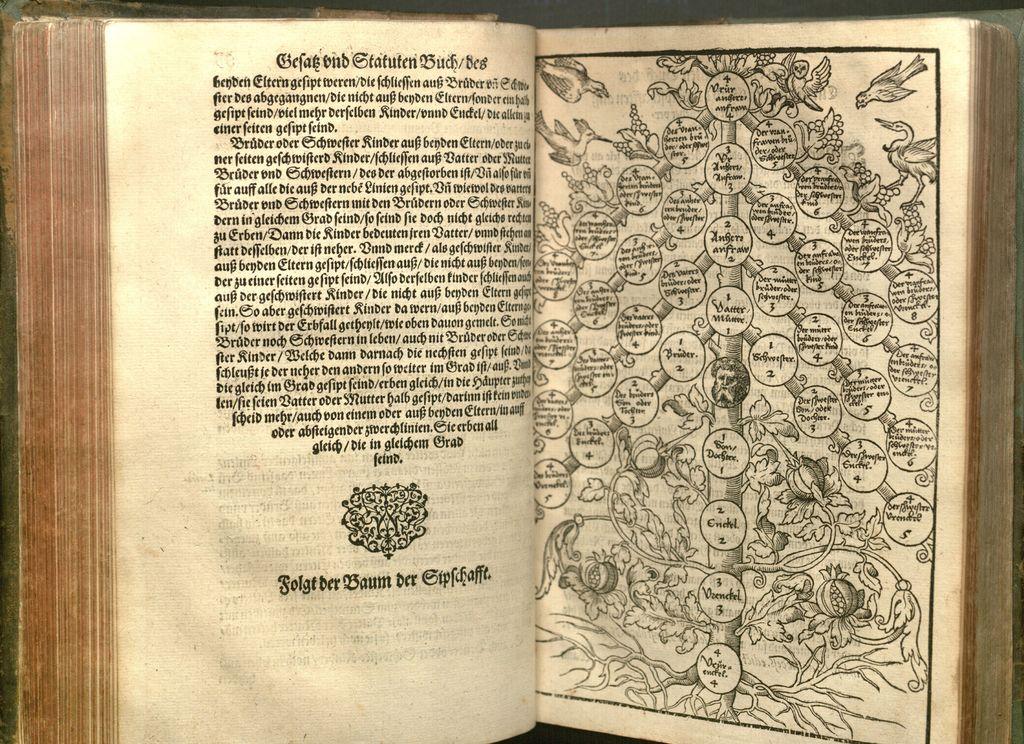This book is more information?
Your answer should be very brief. Yes. 